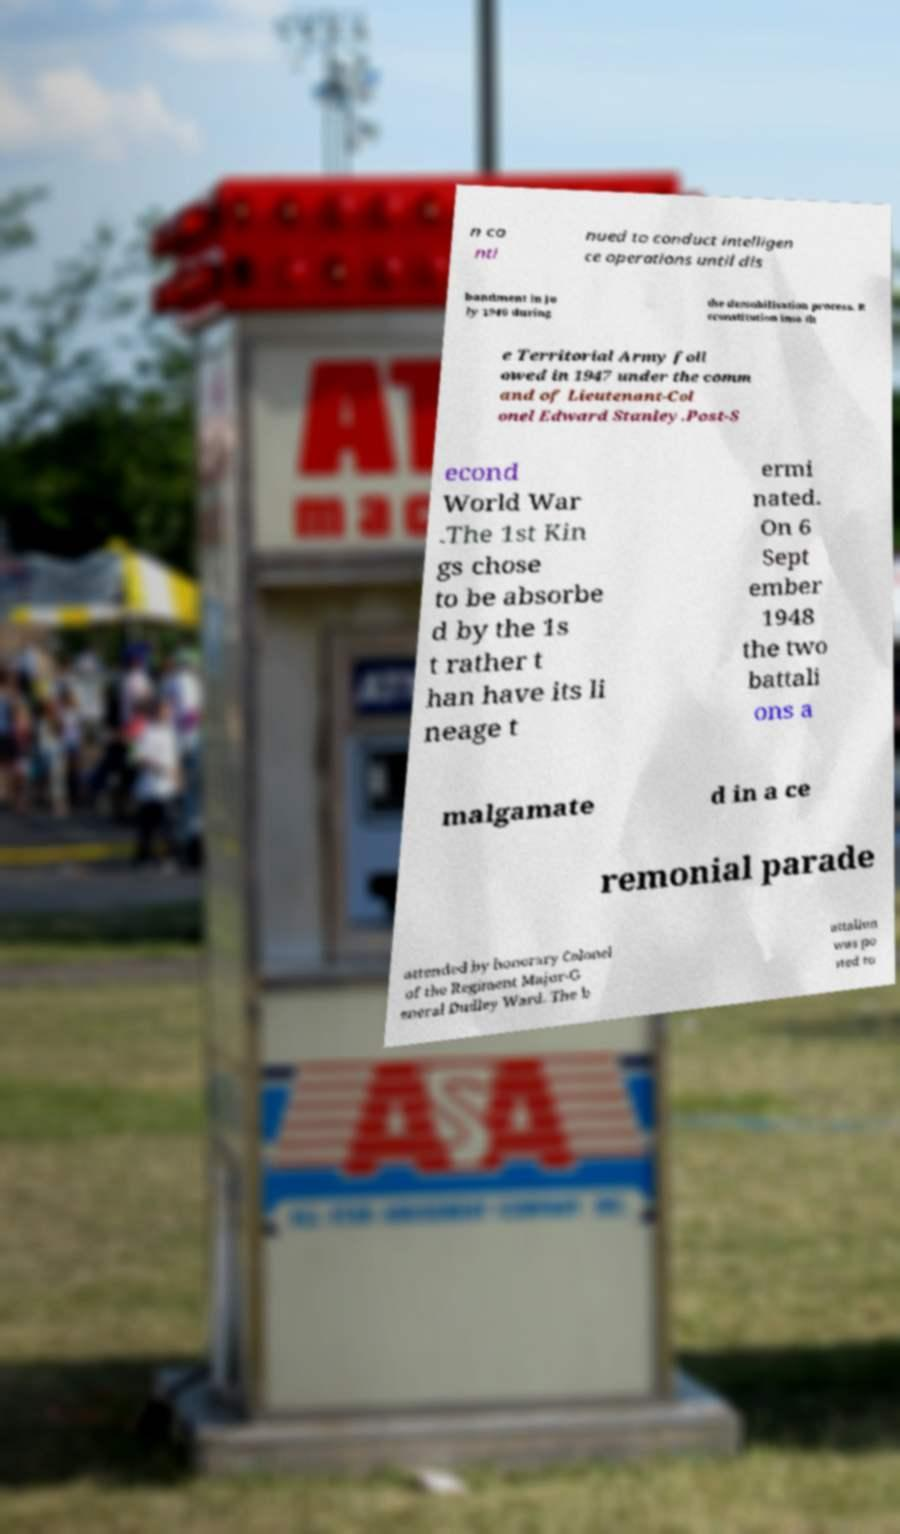Could you assist in decoding the text presented in this image and type it out clearly? n co nti nued to conduct intelligen ce operations until dis bandment in Ju ly 1946 during the demobilisation process. R econstitution into th e Territorial Army foll owed in 1947 under the comm and of Lieutenant-Col onel Edward Stanley.Post-S econd World War .The 1st Kin gs chose to be absorbe d by the 1s t rather t han have its li neage t ermi nated. On 6 Sept ember 1948 the two battali ons a malgamate d in a ce remonial parade attended by honorary Colonel of the Regiment Major-G eneral Dudley Ward. The b attalion was po sted to 